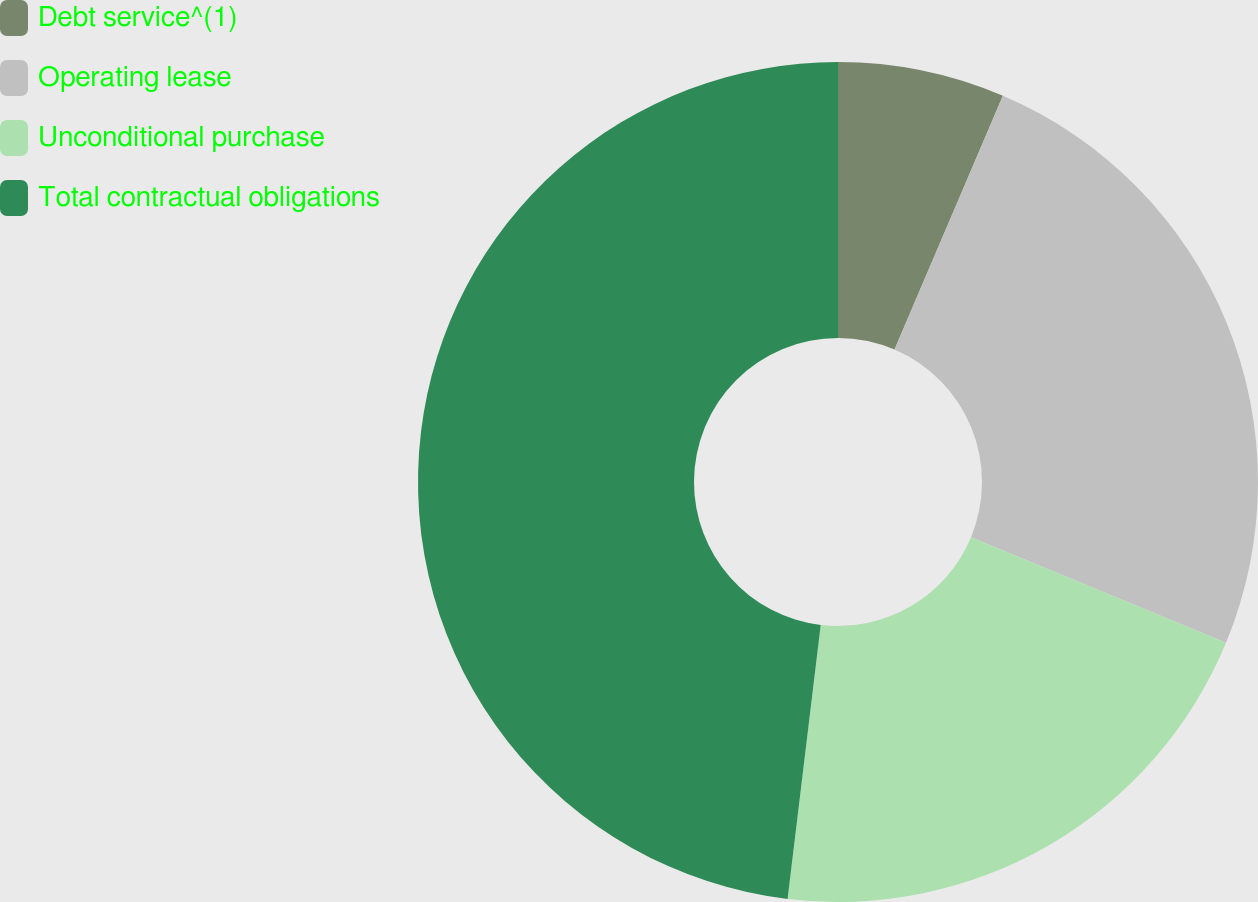Convert chart to OTSL. <chart><loc_0><loc_0><loc_500><loc_500><pie_chart><fcel>Debt service^(1)<fcel>Operating lease<fcel>Unconditional purchase<fcel>Total contractual obligations<nl><fcel>6.42%<fcel>24.83%<fcel>20.66%<fcel>48.08%<nl></chart> 